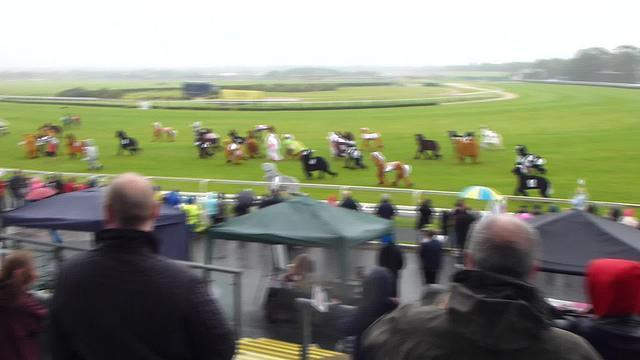How many awnings are there?
Answer the question by selecting the correct answer among the 4 following choices.
Options: Eight, three, none, four. Three. 